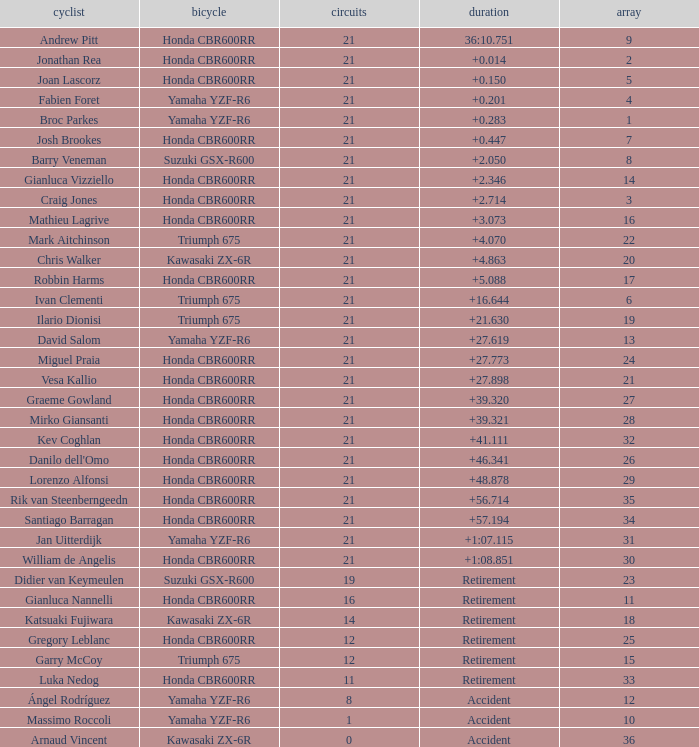Would you mind parsing the complete table? {'header': ['cyclist', 'bicycle', 'circuits', 'duration', 'array'], 'rows': [['Andrew Pitt', 'Honda CBR600RR', '21', '36:10.751', '9'], ['Jonathan Rea', 'Honda CBR600RR', '21', '+0.014', '2'], ['Joan Lascorz', 'Honda CBR600RR', '21', '+0.150', '5'], ['Fabien Foret', 'Yamaha YZF-R6', '21', '+0.201', '4'], ['Broc Parkes', 'Yamaha YZF-R6', '21', '+0.283', '1'], ['Josh Brookes', 'Honda CBR600RR', '21', '+0.447', '7'], ['Barry Veneman', 'Suzuki GSX-R600', '21', '+2.050', '8'], ['Gianluca Vizziello', 'Honda CBR600RR', '21', '+2.346', '14'], ['Craig Jones', 'Honda CBR600RR', '21', '+2.714', '3'], ['Mathieu Lagrive', 'Honda CBR600RR', '21', '+3.073', '16'], ['Mark Aitchinson', 'Triumph 675', '21', '+4.070', '22'], ['Chris Walker', 'Kawasaki ZX-6R', '21', '+4.863', '20'], ['Robbin Harms', 'Honda CBR600RR', '21', '+5.088', '17'], ['Ivan Clementi', 'Triumph 675', '21', '+16.644', '6'], ['Ilario Dionisi', 'Triumph 675', '21', '+21.630', '19'], ['David Salom', 'Yamaha YZF-R6', '21', '+27.619', '13'], ['Miguel Praia', 'Honda CBR600RR', '21', '+27.773', '24'], ['Vesa Kallio', 'Honda CBR600RR', '21', '+27.898', '21'], ['Graeme Gowland', 'Honda CBR600RR', '21', '+39.320', '27'], ['Mirko Giansanti', 'Honda CBR600RR', '21', '+39.321', '28'], ['Kev Coghlan', 'Honda CBR600RR', '21', '+41.111', '32'], ["Danilo dell'Omo", 'Honda CBR600RR', '21', '+46.341', '26'], ['Lorenzo Alfonsi', 'Honda CBR600RR', '21', '+48.878', '29'], ['Rik van Steenberngeedn', 'Honda CBR600RR', '21', '+56.714', '35'], ['Santiago Barragan', 'Honda CBR600RR', '21', '+57.194', '34'], ['Jan Uitterdijk', 'Yamaha YZF-R6', '21', '+1:07.115', '31'], ['William de Angelis', 'Honda CBR600RR', '21', '+1:08.851', '30'], ['Didier van Keymeulen', 'Suzuki GSX-R600', '19', 'Retirement', '23'], ['Gianluca Nannelli', 'Honda CBR600RR', '16', 'Retirement', '11'], ['Katsuaki Fujiwara', 'Kawasaki ZX-6R', '14', 'Retirement', '18'], ['Gregory Leblanc', 'Honda CBR600RR', '12', 'Retirement', '25'], ['Garry McCoy', 'Triumph 675', '12', 'Retirement', '15'], ['Luka Nedog', 'Honda CBR600RR', '11', 'Retirement', '33'], ['Ángel Rodríguez', 'Yamaha YZF-R6', '8', 'Accident', '12'], ['Massimo Roccoli', 'Yamaha YZF-R6', '1', 'Accident', '10'], ['Arnaud Vincent', 'Kawasaki ZX-6R', '0', 'Accident', '36']]} What driver had the highest grid position with a time of +0.283? 1.0. 